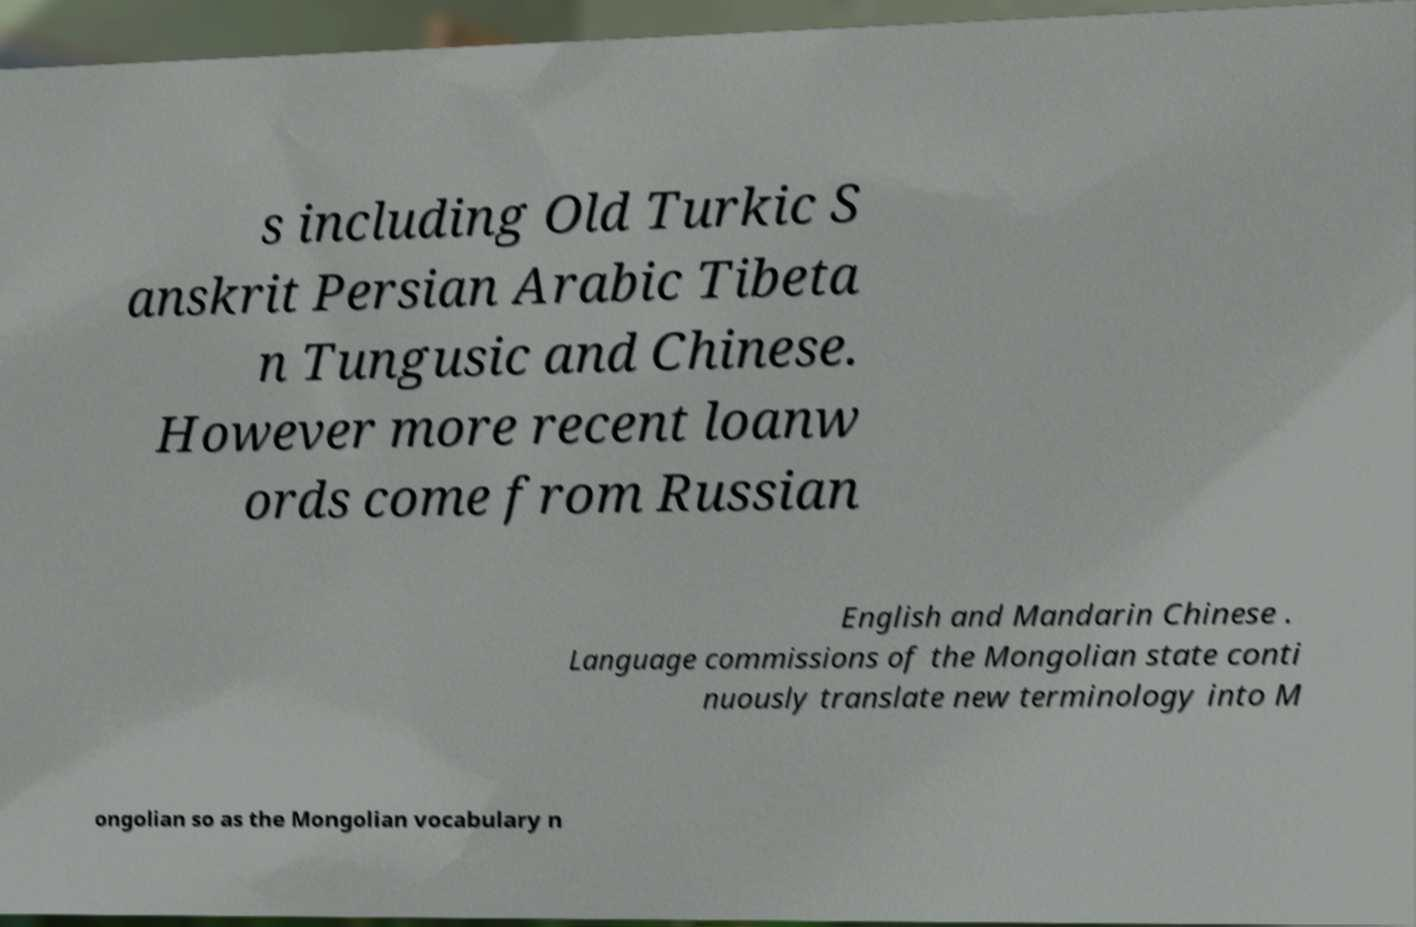For documentation purposes, I need the text within this image transcribed. Could you provide that? s including Old Turkic S anskrit Persian Arabic Tibeta n Tungusic and Chinese. However more recent loanw ords come from Russian English and Mandarin Chinese . Language commissions of the Mongolian state conti nuously translate new terminology into M ongolian so as the Mongolian vocabulary n 